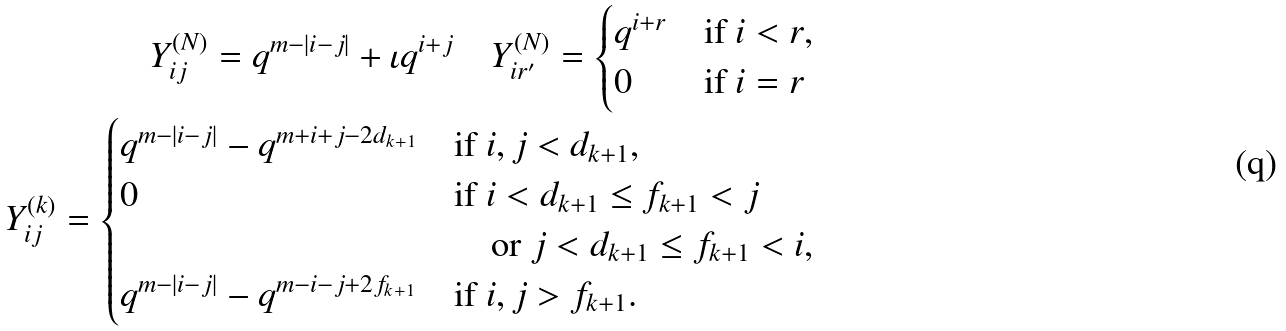Convert formula to latex. <formula><loc_0><loc_0><loc_500><loc_500>Y ^ { ( N ) } _ { i j } = q ^ { m - | i - j | } + \iota q ^ { i + j } \quad Y ^ { ( N ) } _ { i r ^ { \prime } } = \begin{cases} q ^ { i + r } & \text {if $i < r$,} \\ 0 & \text {if $i = r$} \end{cases} \\ Y ^ { ( k ) } _ { i j } = \begin{cases} q ^ { m - | i - j | } - q ^ { m + i + j - 2 d _ { k + 1 } } & \text {if $i,j < d_{k+1}$,} \\ 0 & \text {if $i< d_{k+1} \leq f_{k+1} < j$} \\ & \quad \text {or $j < d_{k+1} \leq f_{k+1} < i$,} \\ q ^ { m - | i - j | } - q ^ { m - i - j + 2 f _ { k + 1 } } & \text {if $i,j > f_{k+1}$.} \end{cases}</formula> 